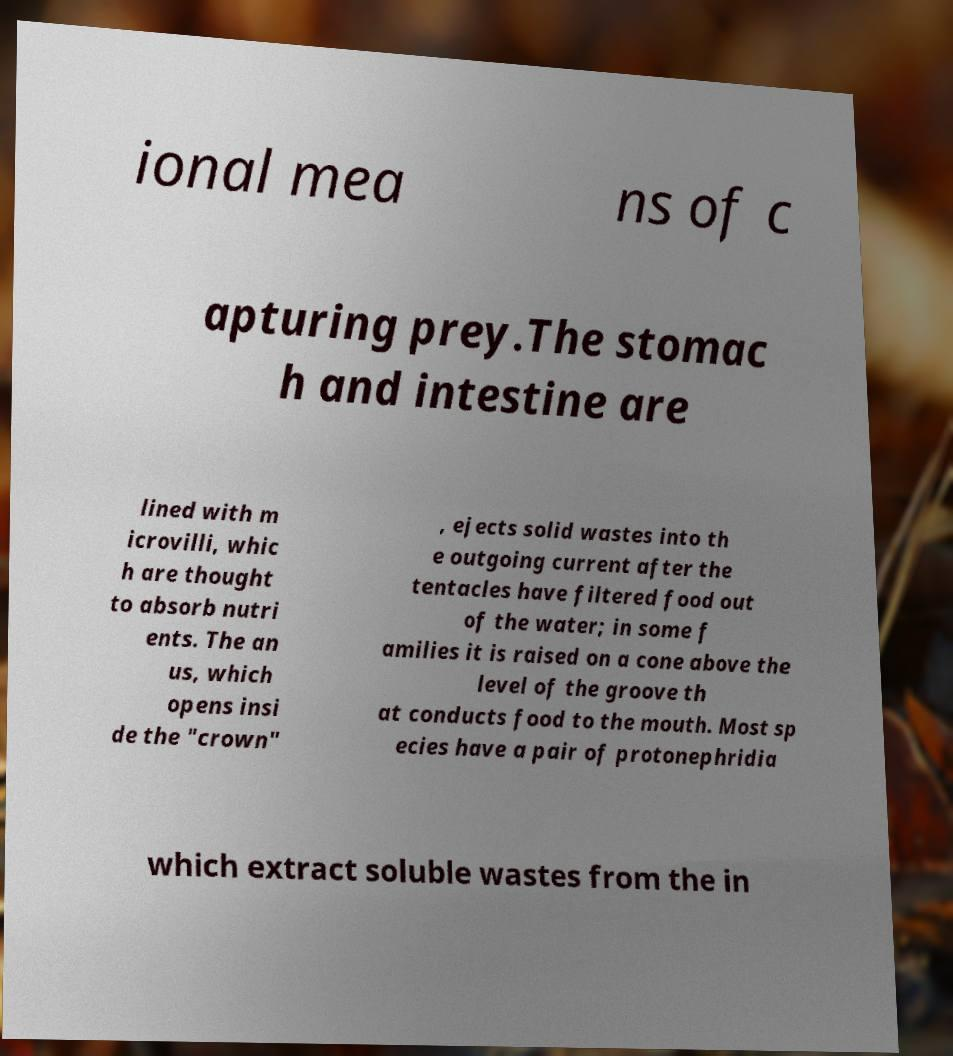There's text embedded in this image that I need extracted. Can you transcribe it verbatim? ional mea ns of c apturing prey.The stomac h and intestine are lined with m icrovilli, whic h are thought to absorb nutri ents. The an us, which opens insi de the "crown" , ejects solid wastes into th e outgoing current after the tentacles have filtered food out of the water; in some f amilies it is raised on a cone above the level of the groove th at conducts food to the mouth. Most sp ecies have a pair of protonephridia which extract soluble wastes from the in 